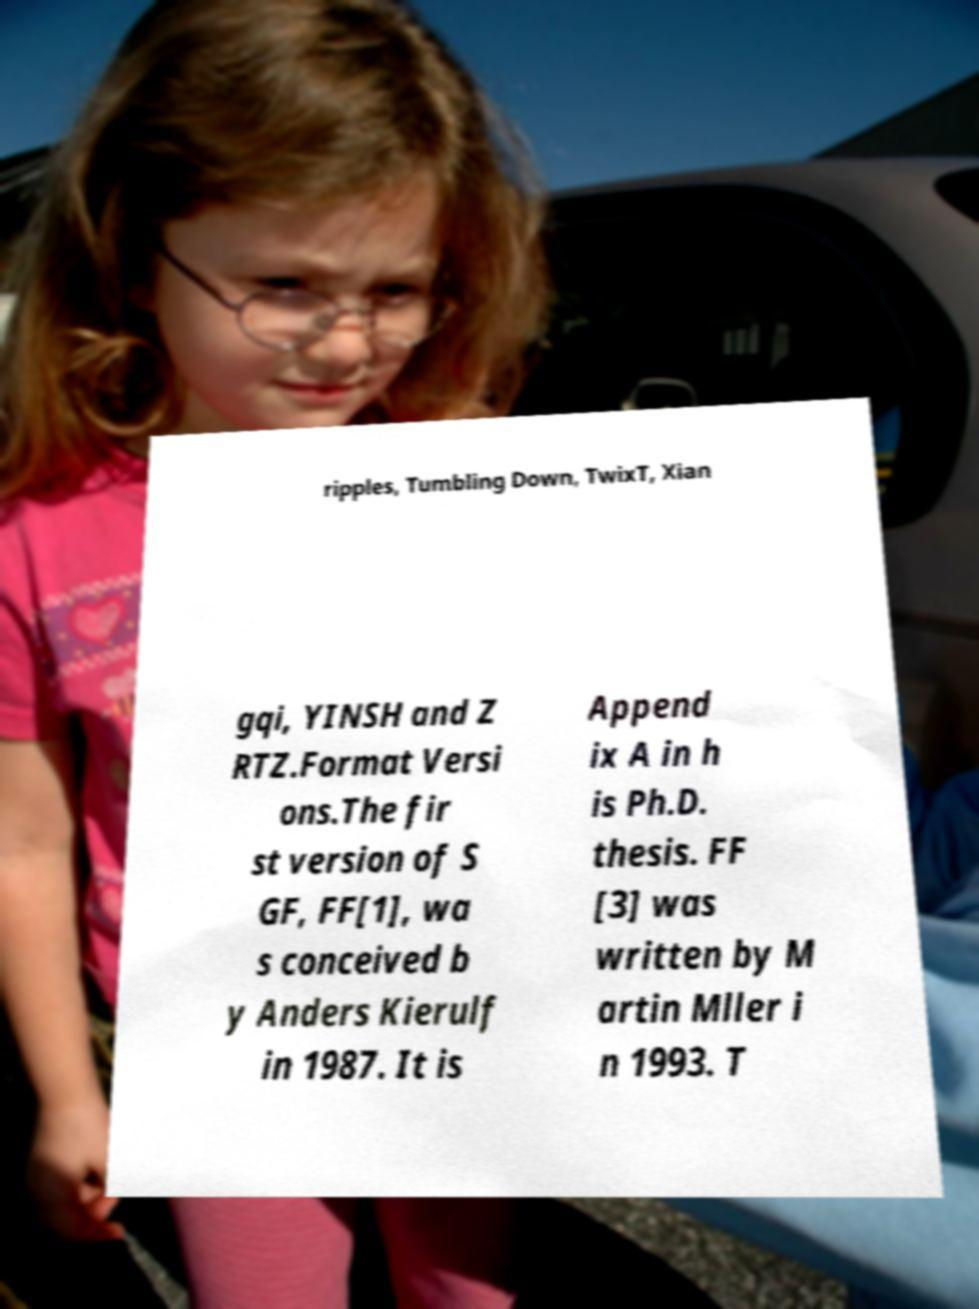Could you extract and type out the text from this image? ripples, Tumbling Down, TwixT, Xian gqi, YINSH and Z RTZ.Format Versi ons.The fir st version of S GF, FF[1], wa s conceived b y Anders Kierulf in 1987. It is Append ix A in h is Ph.D. thesis. FF [3] was written by M artin Mller i n 1993. T 